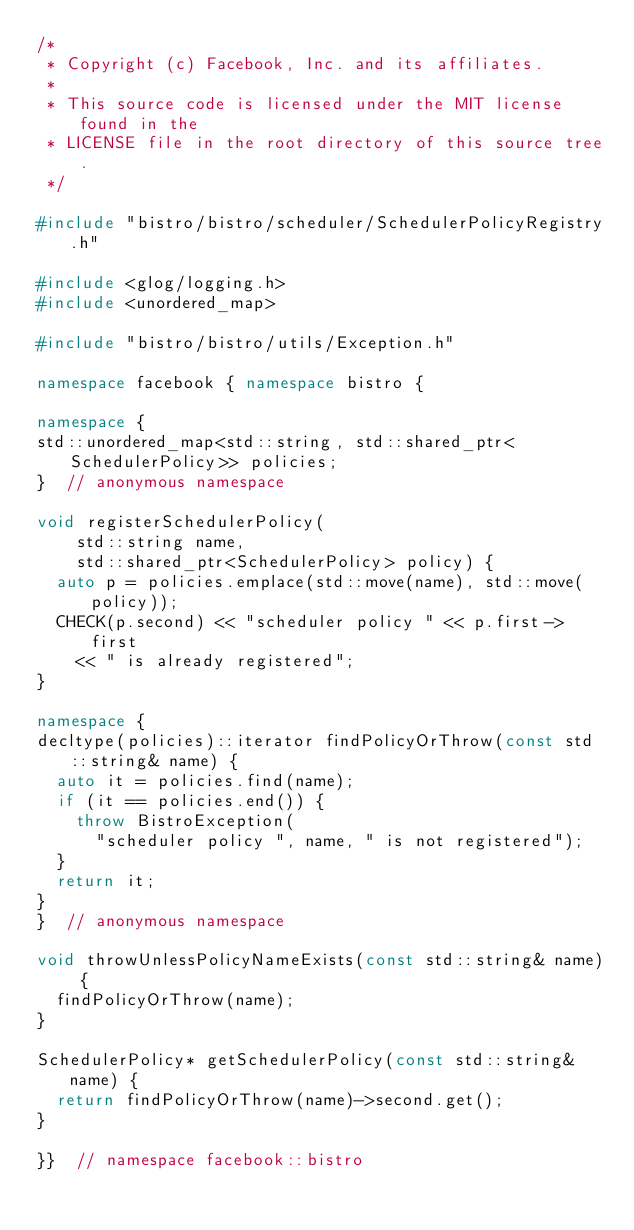<code> <loc_0><loc_0><loc_500><loc_500><_C++_>/*
 * Copyright (c) Facebook, Inc. and its affiliates.
 *
 * This source code is licensed under the MIT license found in the
 * LICENSE file in the root directory of this source tree.
 */

#include "bistro/bistro/scheduler/SchedulerPolicyRegistry.h"

#include <glog/logging.h>
#include <unordered_map>

#include "bistro/bistro/utils/Exception.h"

namespace facebook { namespace bistro {

namespace {
std::unordered_map<std::string, std::shared_ptr<SchedulerPolicy>> policies;
}  // anonymous namespace

void registerSchedulerPolicy(
    std::string name,
    std::shared_ptr<SchedulerPolicy> policy) {
  auto p = policies.emplace(std::move(name), std::move(policy));
  CHECK(p.second) << "scheduler policy " << p.first->first
    << " is already registered";
}

namespace {
decltype(policies)::iterator findPolicyOrThrow(const std::string& name) {
  auto it = policies.find(name);
  if (it == policies.end()) {
    throw BistroException(
      "scheduler policy ", name, " is not registered");
  }
  return it;
}
}  // anonymous namespace

void throwUnlessPolicyNameExists(const std::string& name) {
  findPolicyOrThrow(name);
}

SchedulerPolicy* getSchedulerPolicy(const std::string& name) {
  return findPolicyOrThrow(name)->second.get();
}

}}  // namespace facebook::bistro
</code> 